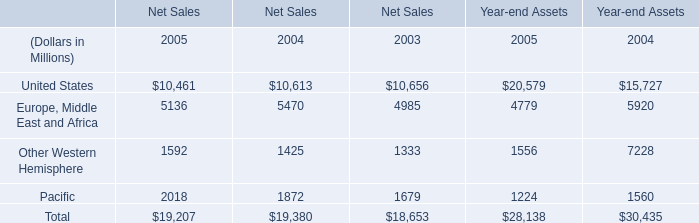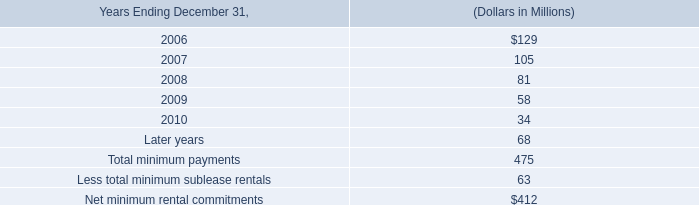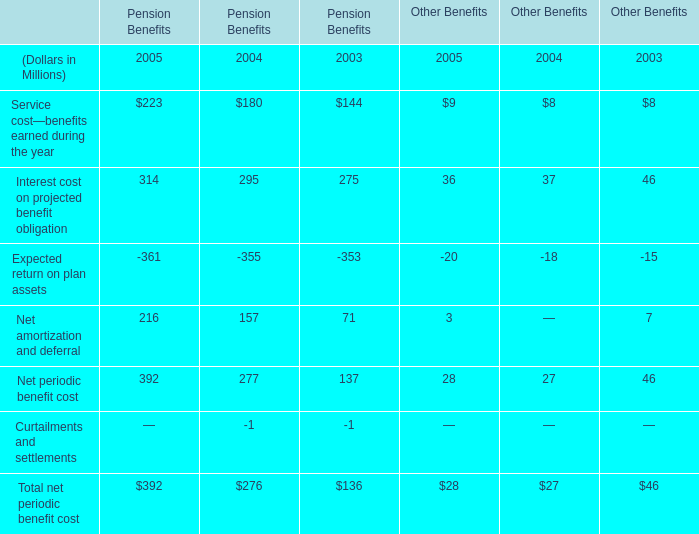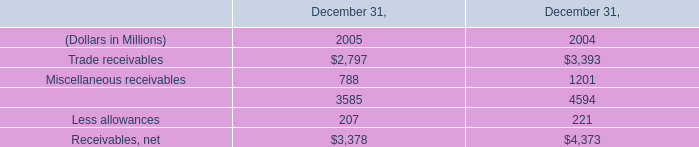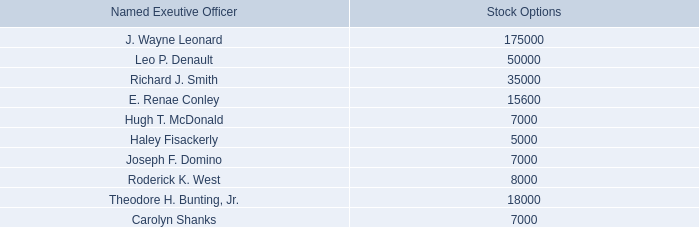What's the average of United States in Net Sales in 2005 and 2004? (in millions) 
Computations: ((10461 + 10613) / 2)
Answer: 10537.0. 